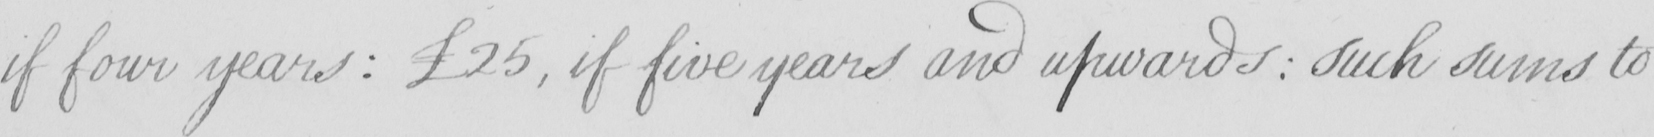What is written in this line of handwriting? if four years :   £25 , if five years and upwards :  such sums to 